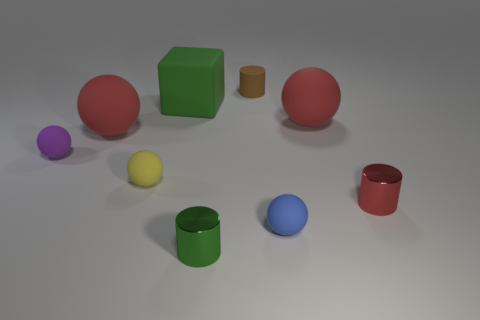There is a object that is both in front of the purple matte thing and on the right side of the tiny blue matte sphere; what is its shape?
Your response must be concise. Cylinder. What is the size of the brown cylinder that is made of the same material as the large green thing?
Provide a succinct answer. Small. How many objects are either small blue things right of the tiny purple rubber object or matte objects behind the purple thing?
Your answer should be compact. 5. Does the red thing that is in front of the purple object have the same size as the green cube?
Your response must be concise. No. What is the color of the rubber thing that is behind the big cube?
Make the answer very short. Brown. The other small metal object that is the same shape as the small green object is what color?
Give a very brief answer. Red. What number of small matte cylinders are to the right of the tiny cylinder in front of the metallic thing on the right side of the small blue ball?
Give a very brief answer. 1. Are there fewer tiny red objects in front of the tiny blue matte thing than big yellow blocks?
Offer a very short reply. No. What number of large red things are made of the same material as the red cylinder?
Make the answer very short. 0. Do the tiny blue sphere that is behind the tiny green metallic cylinder and the big green thing have the same material?
Ensure brevity in your answer.  Yes. 